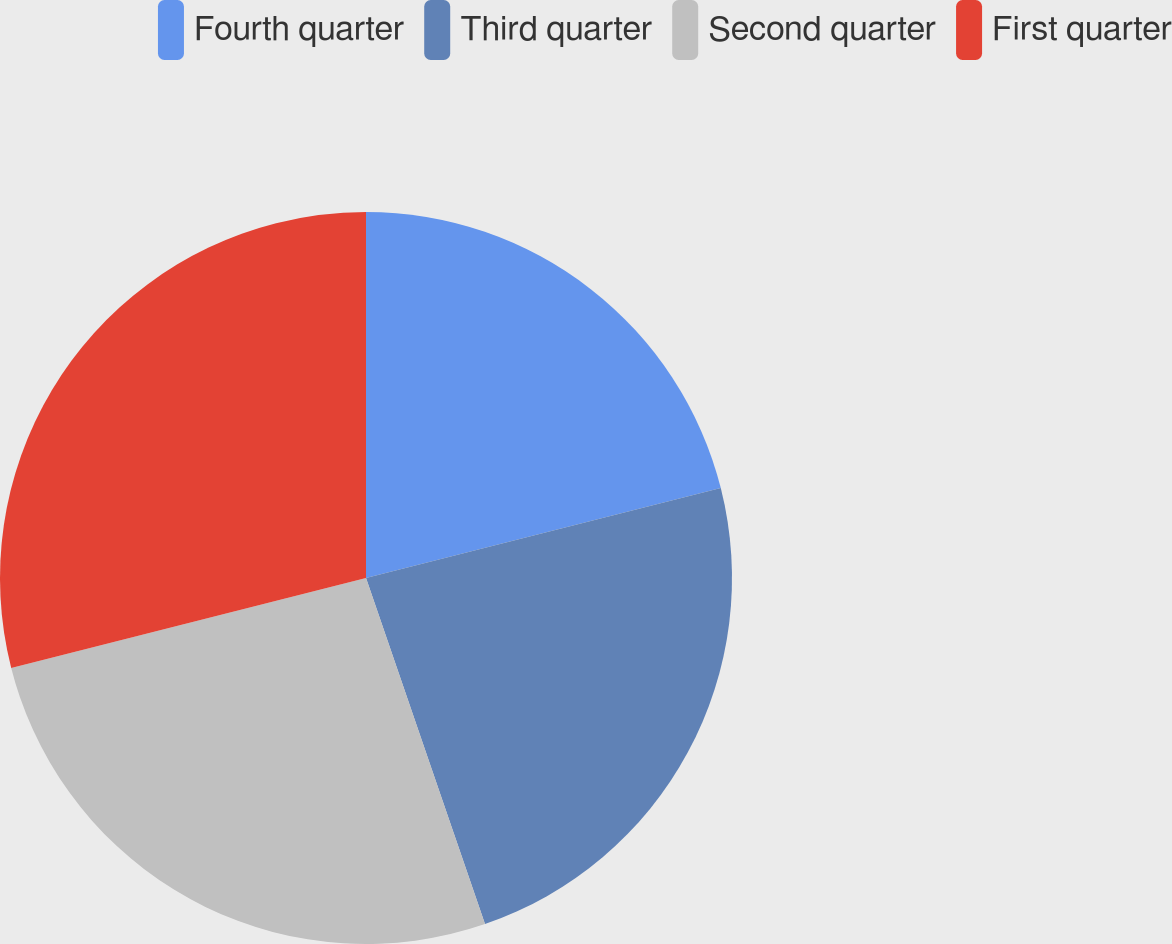Convert chart. <chart><loc_0><loc_0><loc_500><loc_500><pie_chart><fcel>Fourth quarter<fcel>Third quarter<fcel>Second quarter<fcel>First quarter<nl><fcel>21.05%<fcel>23.68%<fcel>26.32%<fcel>28.95%<nl></chart> 